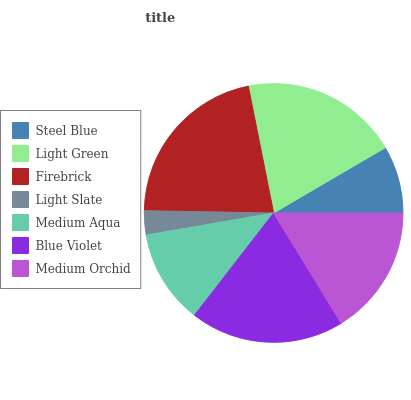Is Light Slate the minimum?
Answer yes or no. Yes. Is Firebrick the maximum?
Answer yes or no. Yes. Is Light Green the minimum?
Answer yes or no. No. Is Light Green the maximum?
Answer yes or no. No. Is Light Green greater than Steel Blue?
Answer yes or no. Yes. Is Steel Blue less than Light Green?
Answer yes or no. Yes. Is Steel Blue greater than Light Green?
Answer yes or no. No. Is Light Green less than Steel Blue?
Answer yes or no. No. Is Medium Orchid the high median?
Answer yes or no. Yes. Is Medium Orchid the low median?
Answer yes or no. Yes. Is Firebrick the high median?
Answer yes or no. No. Is Blue Violet the low median?
Answer yes or no. No. 